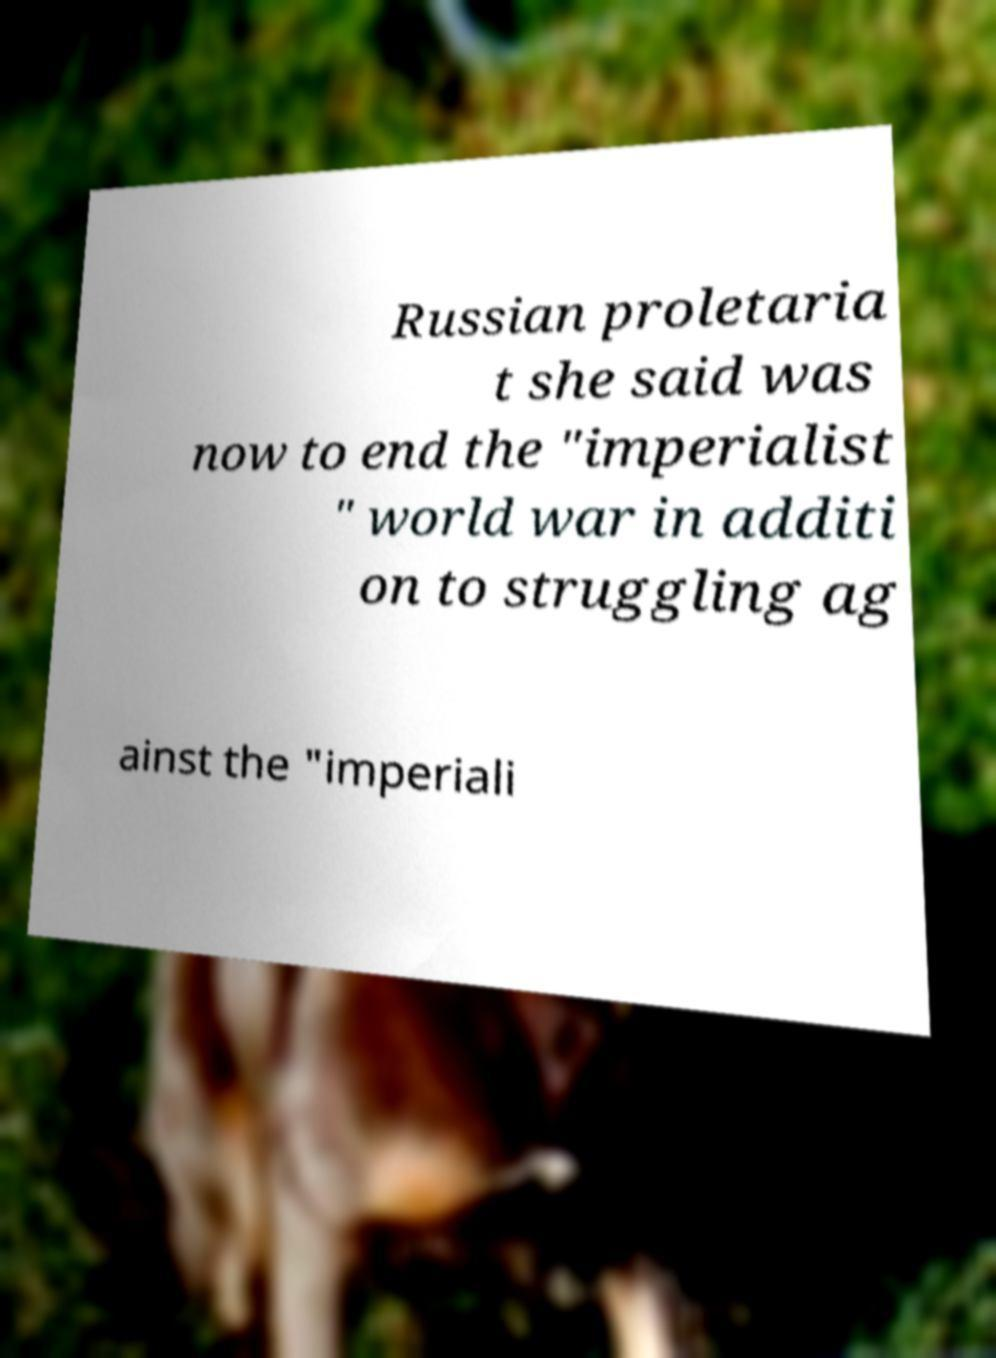Can you read and provide the text displayed in the image?This photo seems to have some interesting text. Can you extract and type it out for me? Russian proletaria t she said was now to end the "imperialist " world war in additi on to struggling ag ainst the "imperiali 